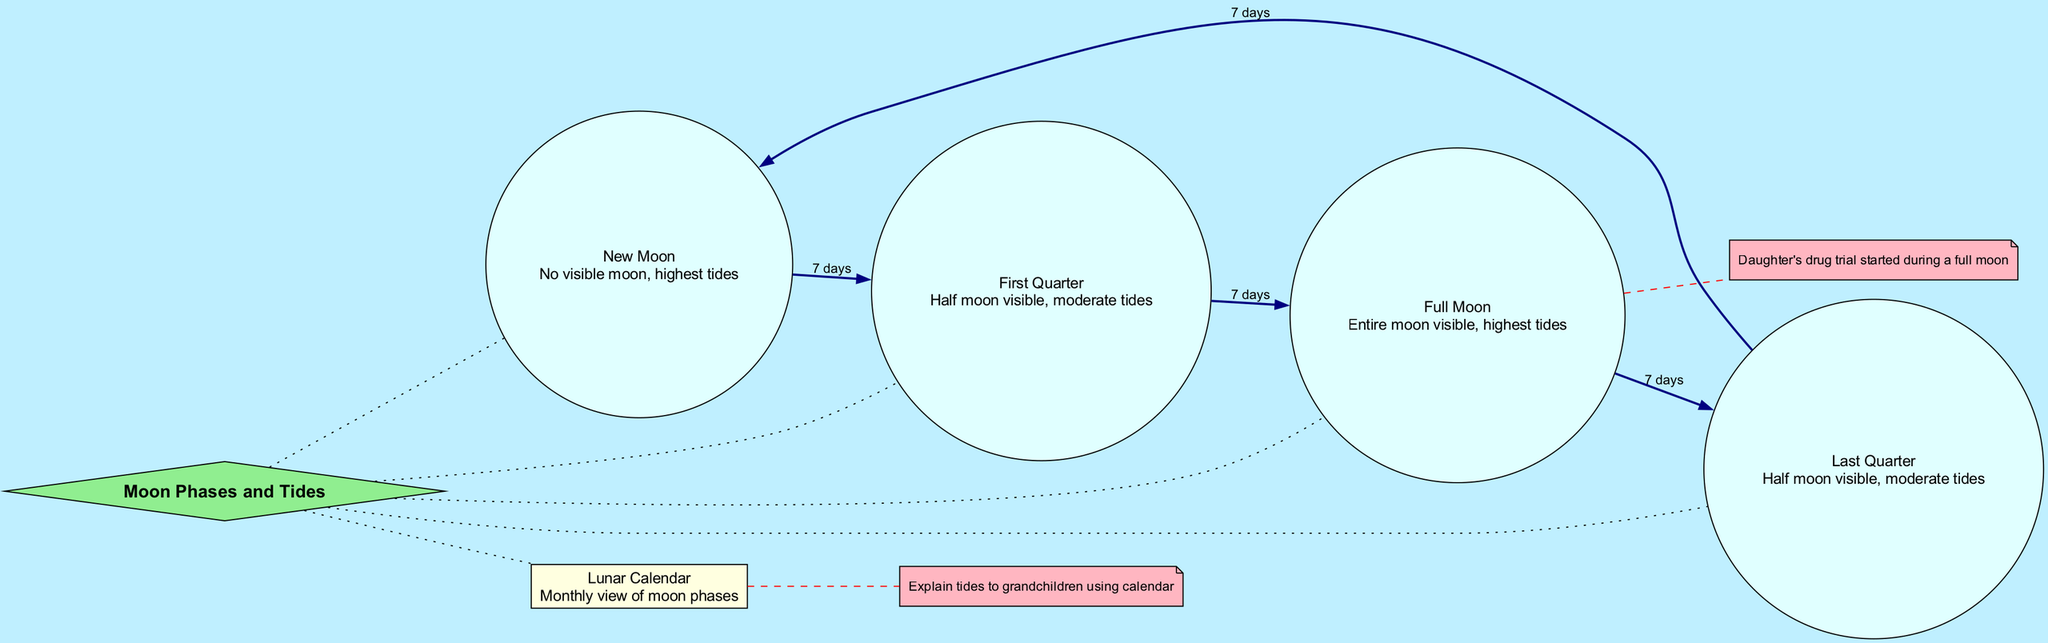What are the two phases of the Moon that show a half moon visible? The diagram identifies the First Quarter and Last Quarter phases as having a half moon visible. These descriptions are found directly associated with both nodes.
Answer: First Quarter and Last Quarter What is the duration from New Moon to Full Moon? To find the duration from New Moon to Full Moon, we observe that the New Moon connects to the First Quarter (7 days) and then to the Full Moon (another 7 days). Adding them gives a total of 14 days.
Answer: 14 days How many nodes are in the diagram? By counting each distinct entry in the nodes section, we find there are five nodes: New Moon, First Quarter, Full Moon, Last Quarter, and Lunar Calendar.
Answer: 5 What is the highest tide associated with? According to the descriptions in the nodes, the highest tides are associated with both the New Moon and the Full Moon phases.
Answer: New Moon and Full Moon What is the connection duration between any two adjacent Moon phases? The diagram indicates that each connection between adjacent Moon phases, such as New Moon to First Quarter or First Quarter to Full Moon, has a duration of 7 days.
Answer: 7 days How did the drug trial relate to the lunar phase? The annotation states that the daughter's drug trial started during a Full Moon, connecting the event directly with that lunar phase.
Answer: Full Moon What can help explain tides to grandchildren? The Lunar Calendar provides a monthly view of the moon phases, which is suggested as a tool to explain tides to grandchildren by visually connecting lunar phases and tides.
Answer: Lunar Calendar What connects Last Quarter back to New Moon? The connection from Last Quarter back to New Moon is illustrated as a duration of 7 days, highlighting the cyclical nature of the lunar phases.
Answer: 7 days 